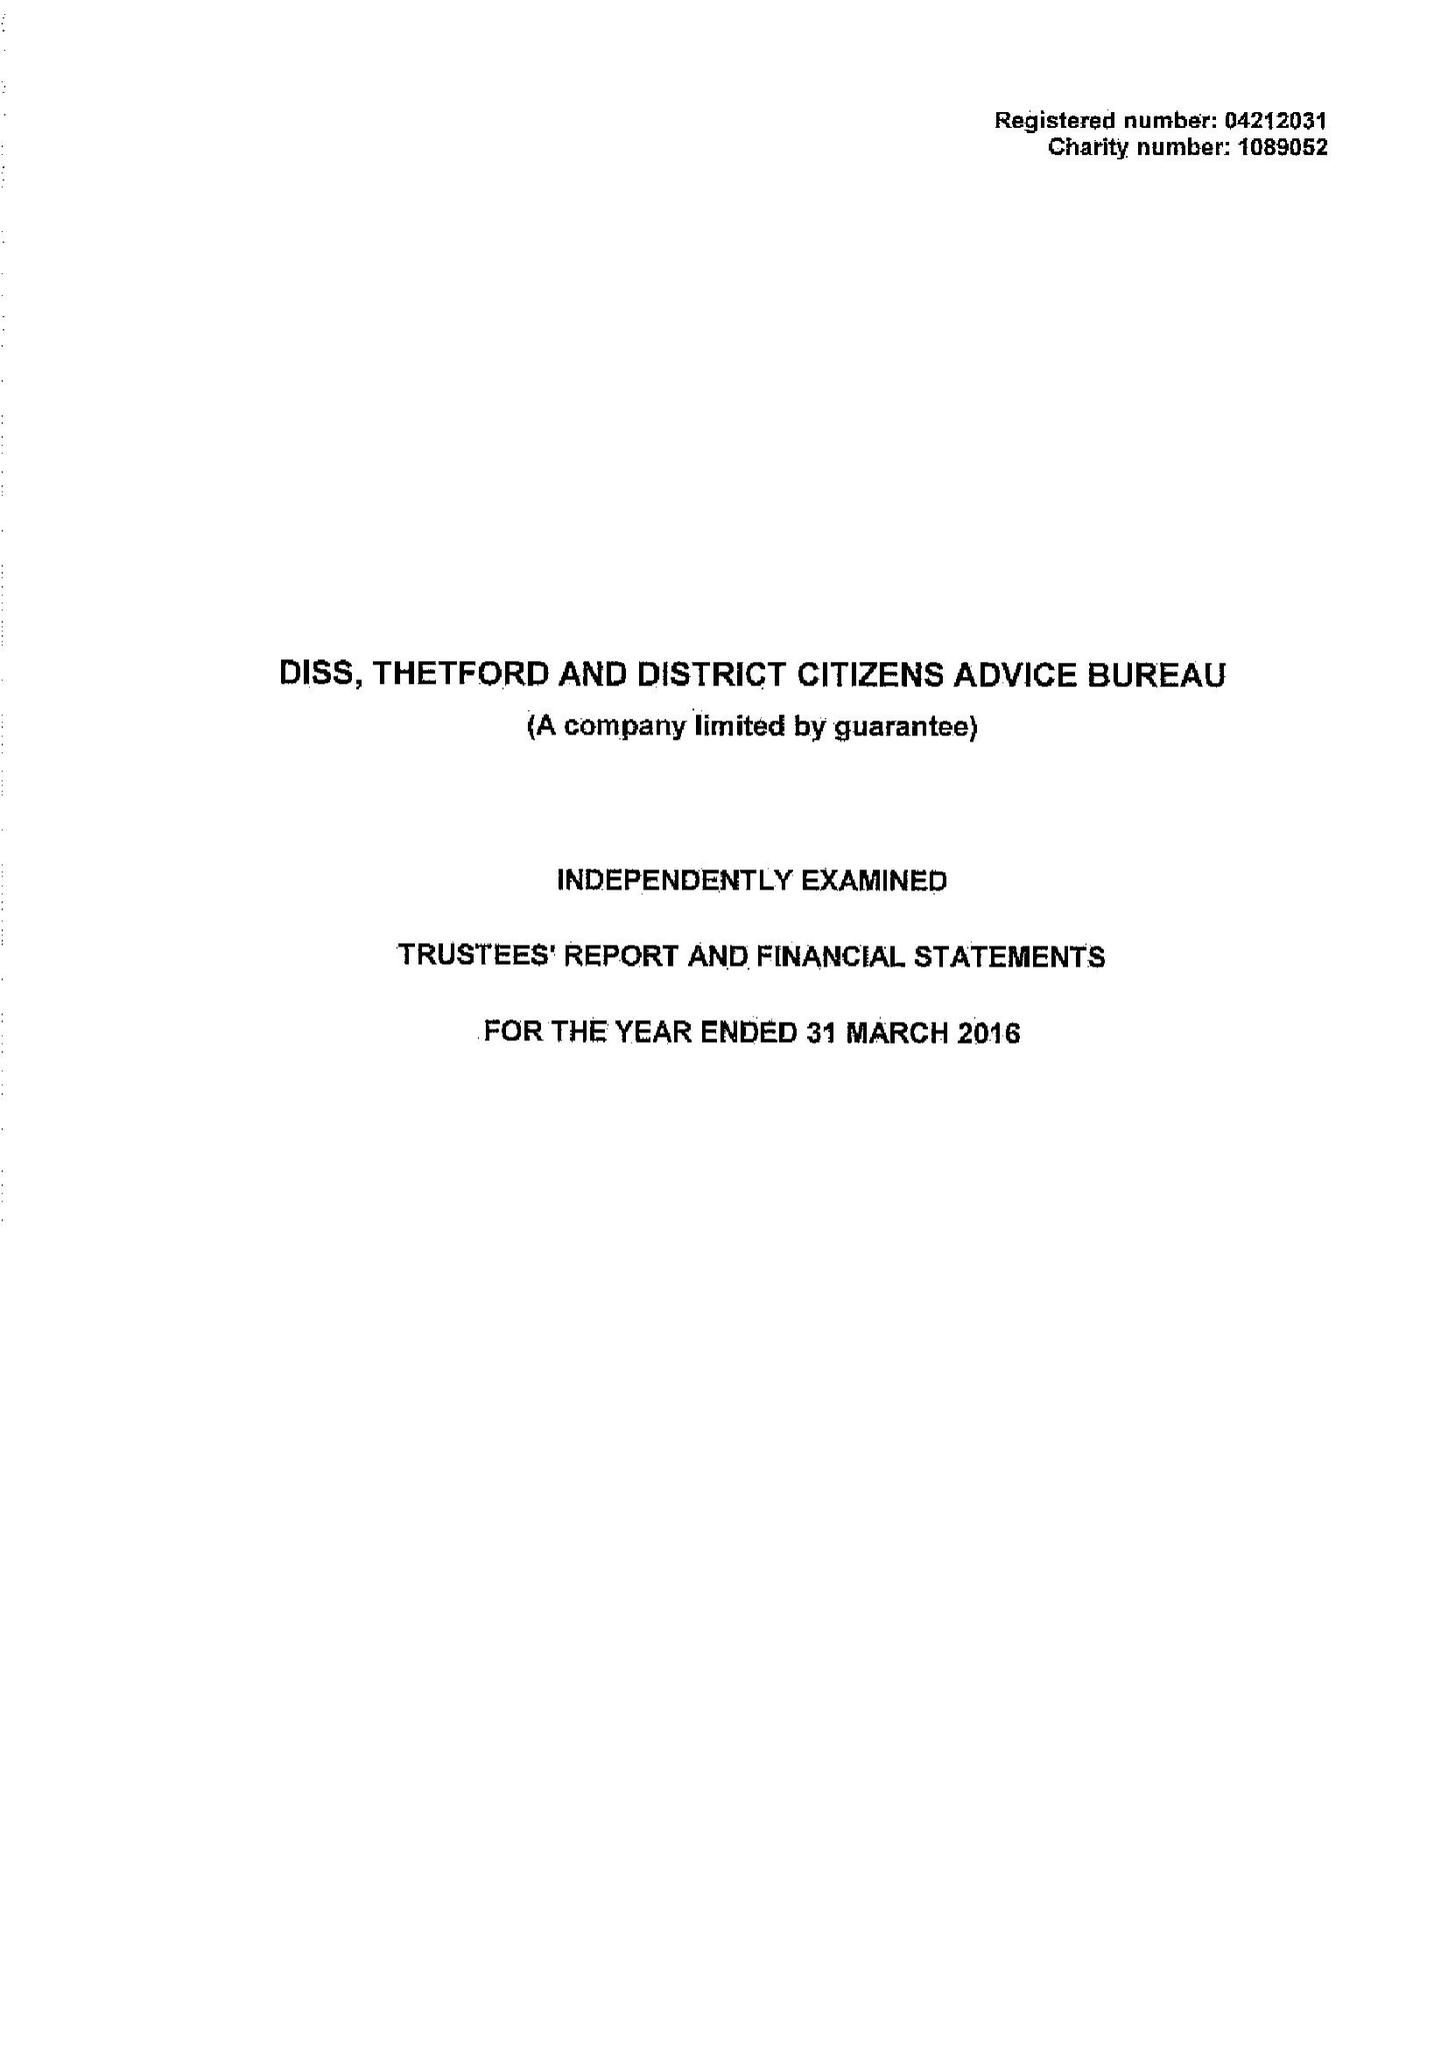What is the value for the report_date?
Answer the question using a single word or phrase. 2016-03-31 